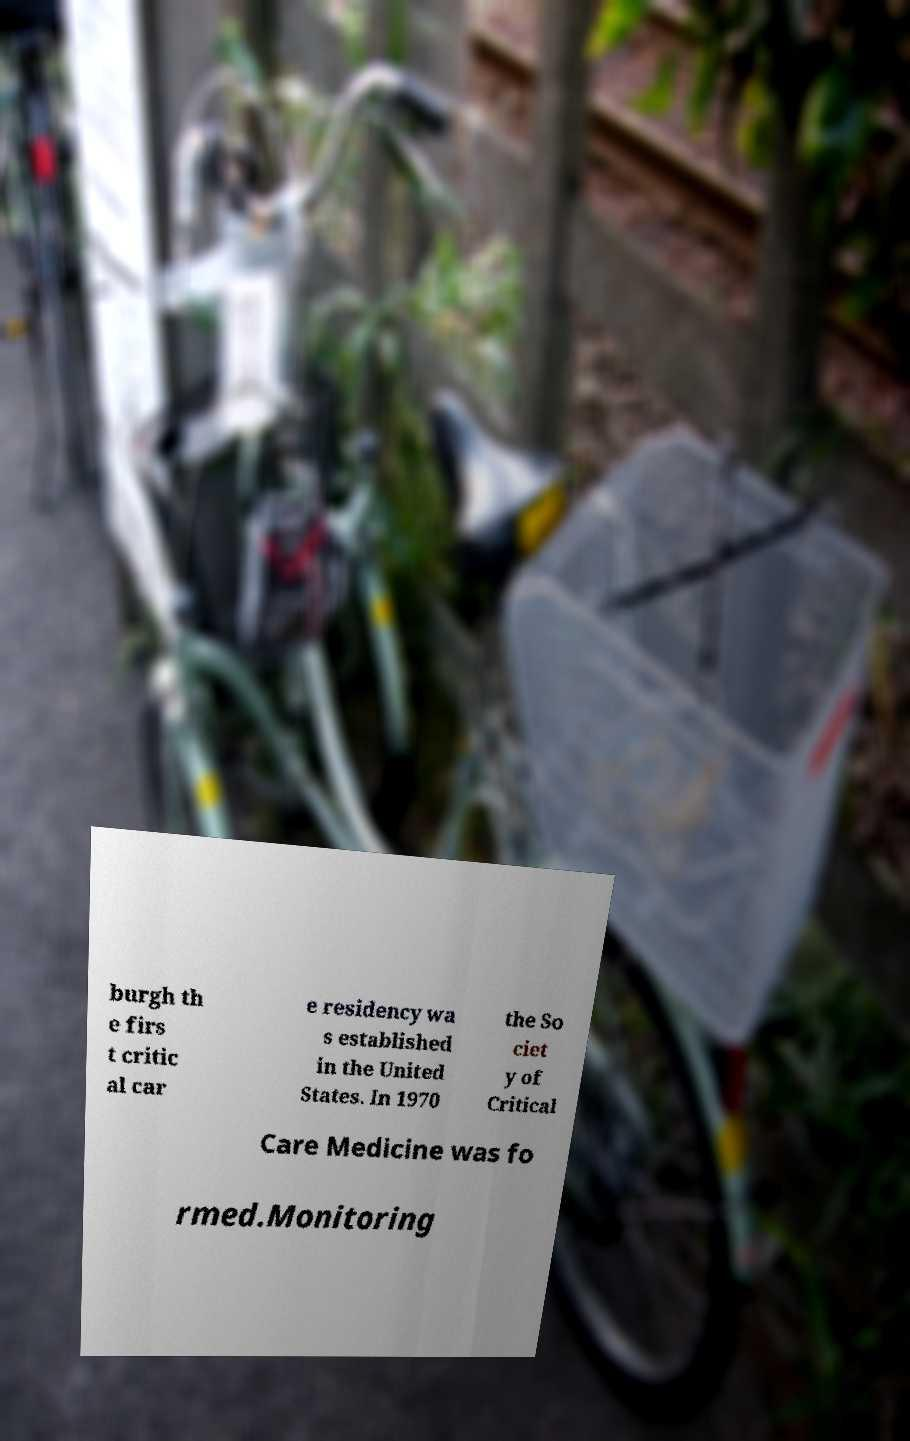Please identify and transcribe the text found in this image. burgh th e firs t critic al car e residency wa s established in the United States. In 1970 the So ciet y of Critical Care Medicine was fo rmed.Monitoring 